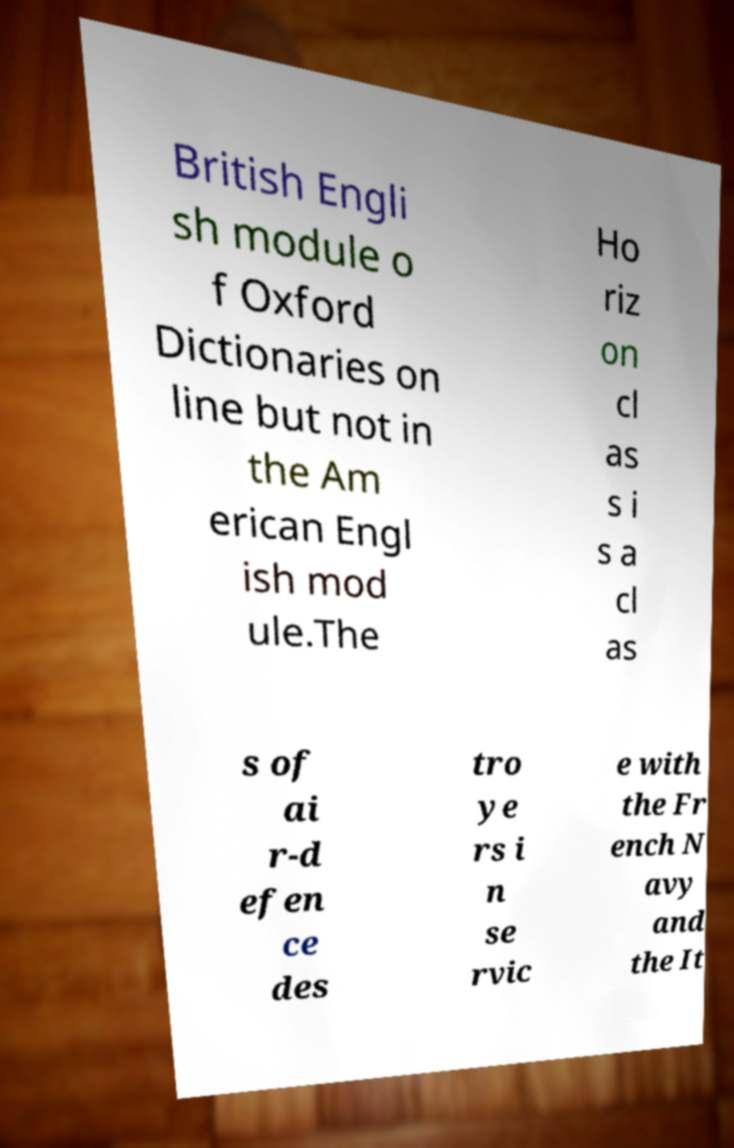I need the written content from this picture converted into text. Can you do that? British Engli sh module o f Oxford Dictionaries on line but not in the Am erican Engl ish mod ule.The Ho riz on cl as s i s a cl as s of ai r-d efen ce des tro ye rs i n se rvic e with the Fr ench N avy and the It 